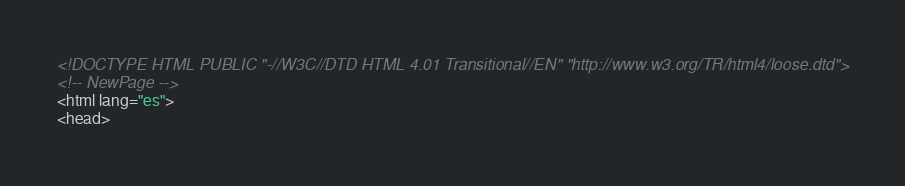<code> <loc_0><loc_0><loc_500><loc_500><_HTML_><!DOCTYPE HTML PUBLIC "-//W3C//DTD HTML 4.01 Transitional//EN" "http://www.w3.org/TR/html4/loose.dtd">
<!-- NewPage -->
<html lang="es">
<head></code> 